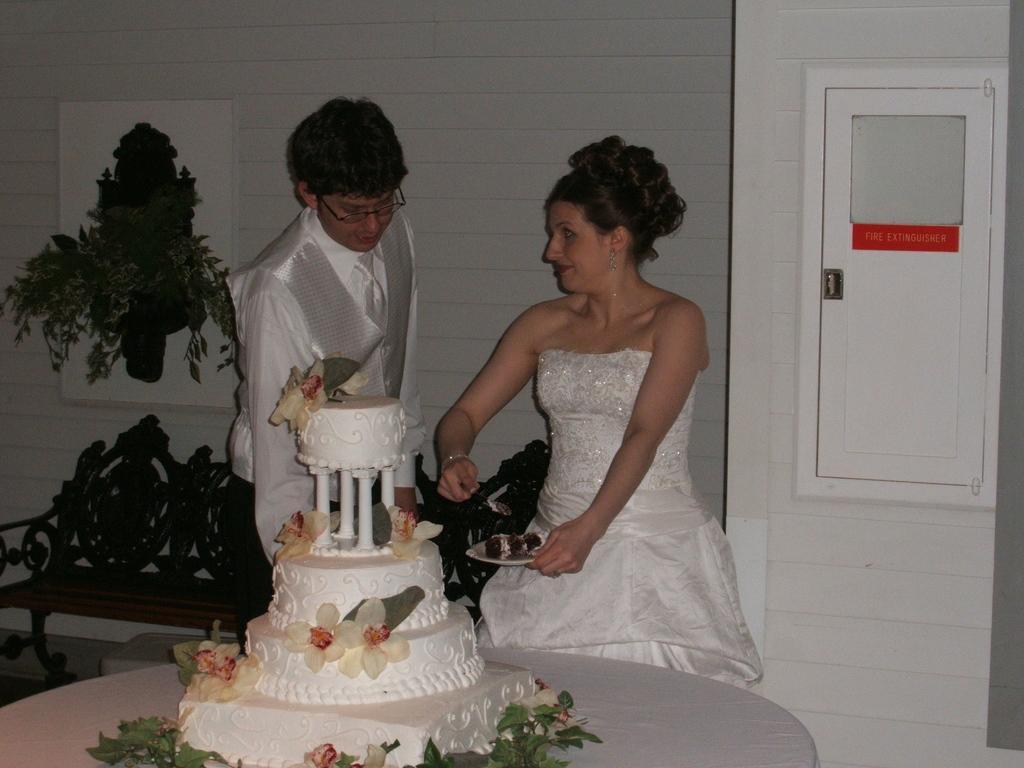How would you summarize this image in a sentence or two? In this image, we can see a man and a woman standing, there is a table, on that table there is a cake, in the background at the right side there is a white color door, at the left side we can see a bench and a wall. 